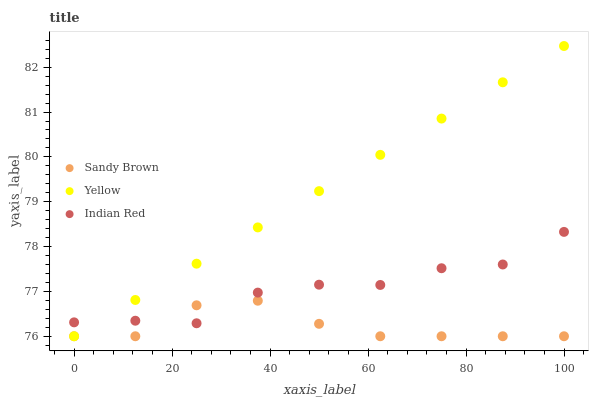Does Sandy Brown have the minimum area under the curve?
Answer yes or no. Yes. Does Yellow have the maximum area under the curve?
Answer yes or no. Yes. Does Indian Red have the minimum area under the curve?
Answer yes or no. No. Does Indian Red have the maximum area under the curve?
Answer yes or no. No. Is Yellow the smoothest?
Answer yes or no. Yes. Is Indian Red the roughest?
Answer yes or no. Yes. Is Indian Red the smoothest?
Answer yes or no. No. Is Yellow the roughest?
Answer yes or no. No. Does Sandy Brown have the lowest value?
Answer yes or no. Yes. Does Indian Red have the lowest value?
Answer yes or no. No. Does Yellow have the highest value?
Answer yes or no. Yes. Does Indian Red have the highest value?
Answer yes or no. No. Does Sandy Brown intersect Yellow?
Answer yes or no. Yes. Is Sandy Brown less than Yellow?
Answer yes or no. No. Is Sandy Brown greater than Yellow?
Answer yes or no. No. 